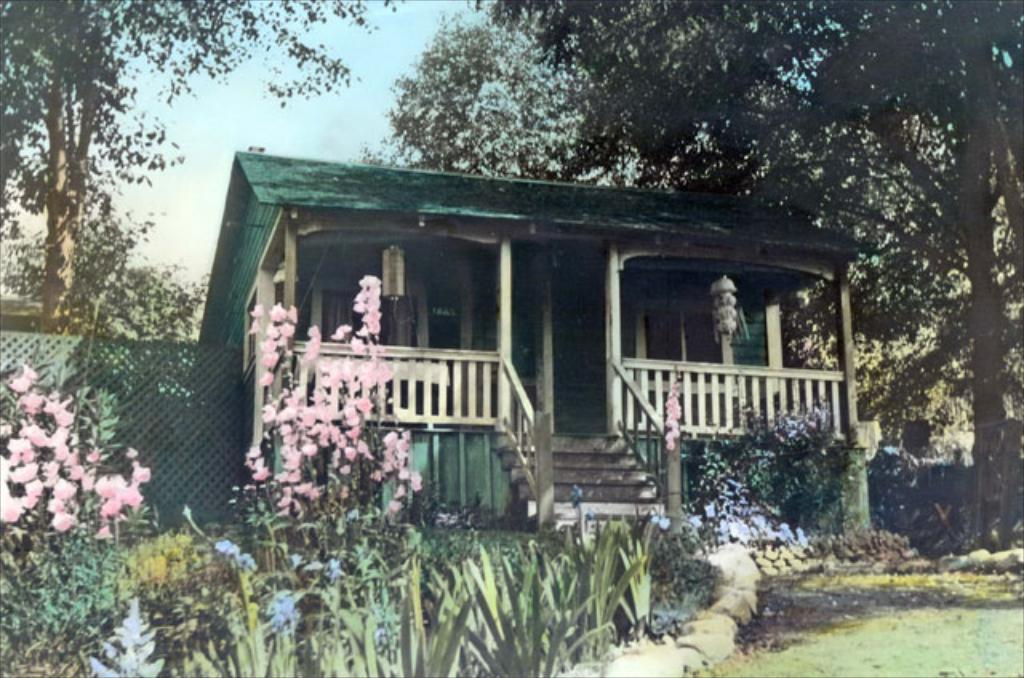What type of structure is visible in the image? There is a house in the image. What type of vegetation can be seen in the image? There is grass, plants, flowers, and trees in the image. What is visible at the top of the image? The sky is visible at the top of the image. How many boats are visible in the image? There are no boats present in the image. What type of pleasure can be derived from the plants in the image? The image does not convey any information about the pleasure derived from the plants; it simply shows their presence. 